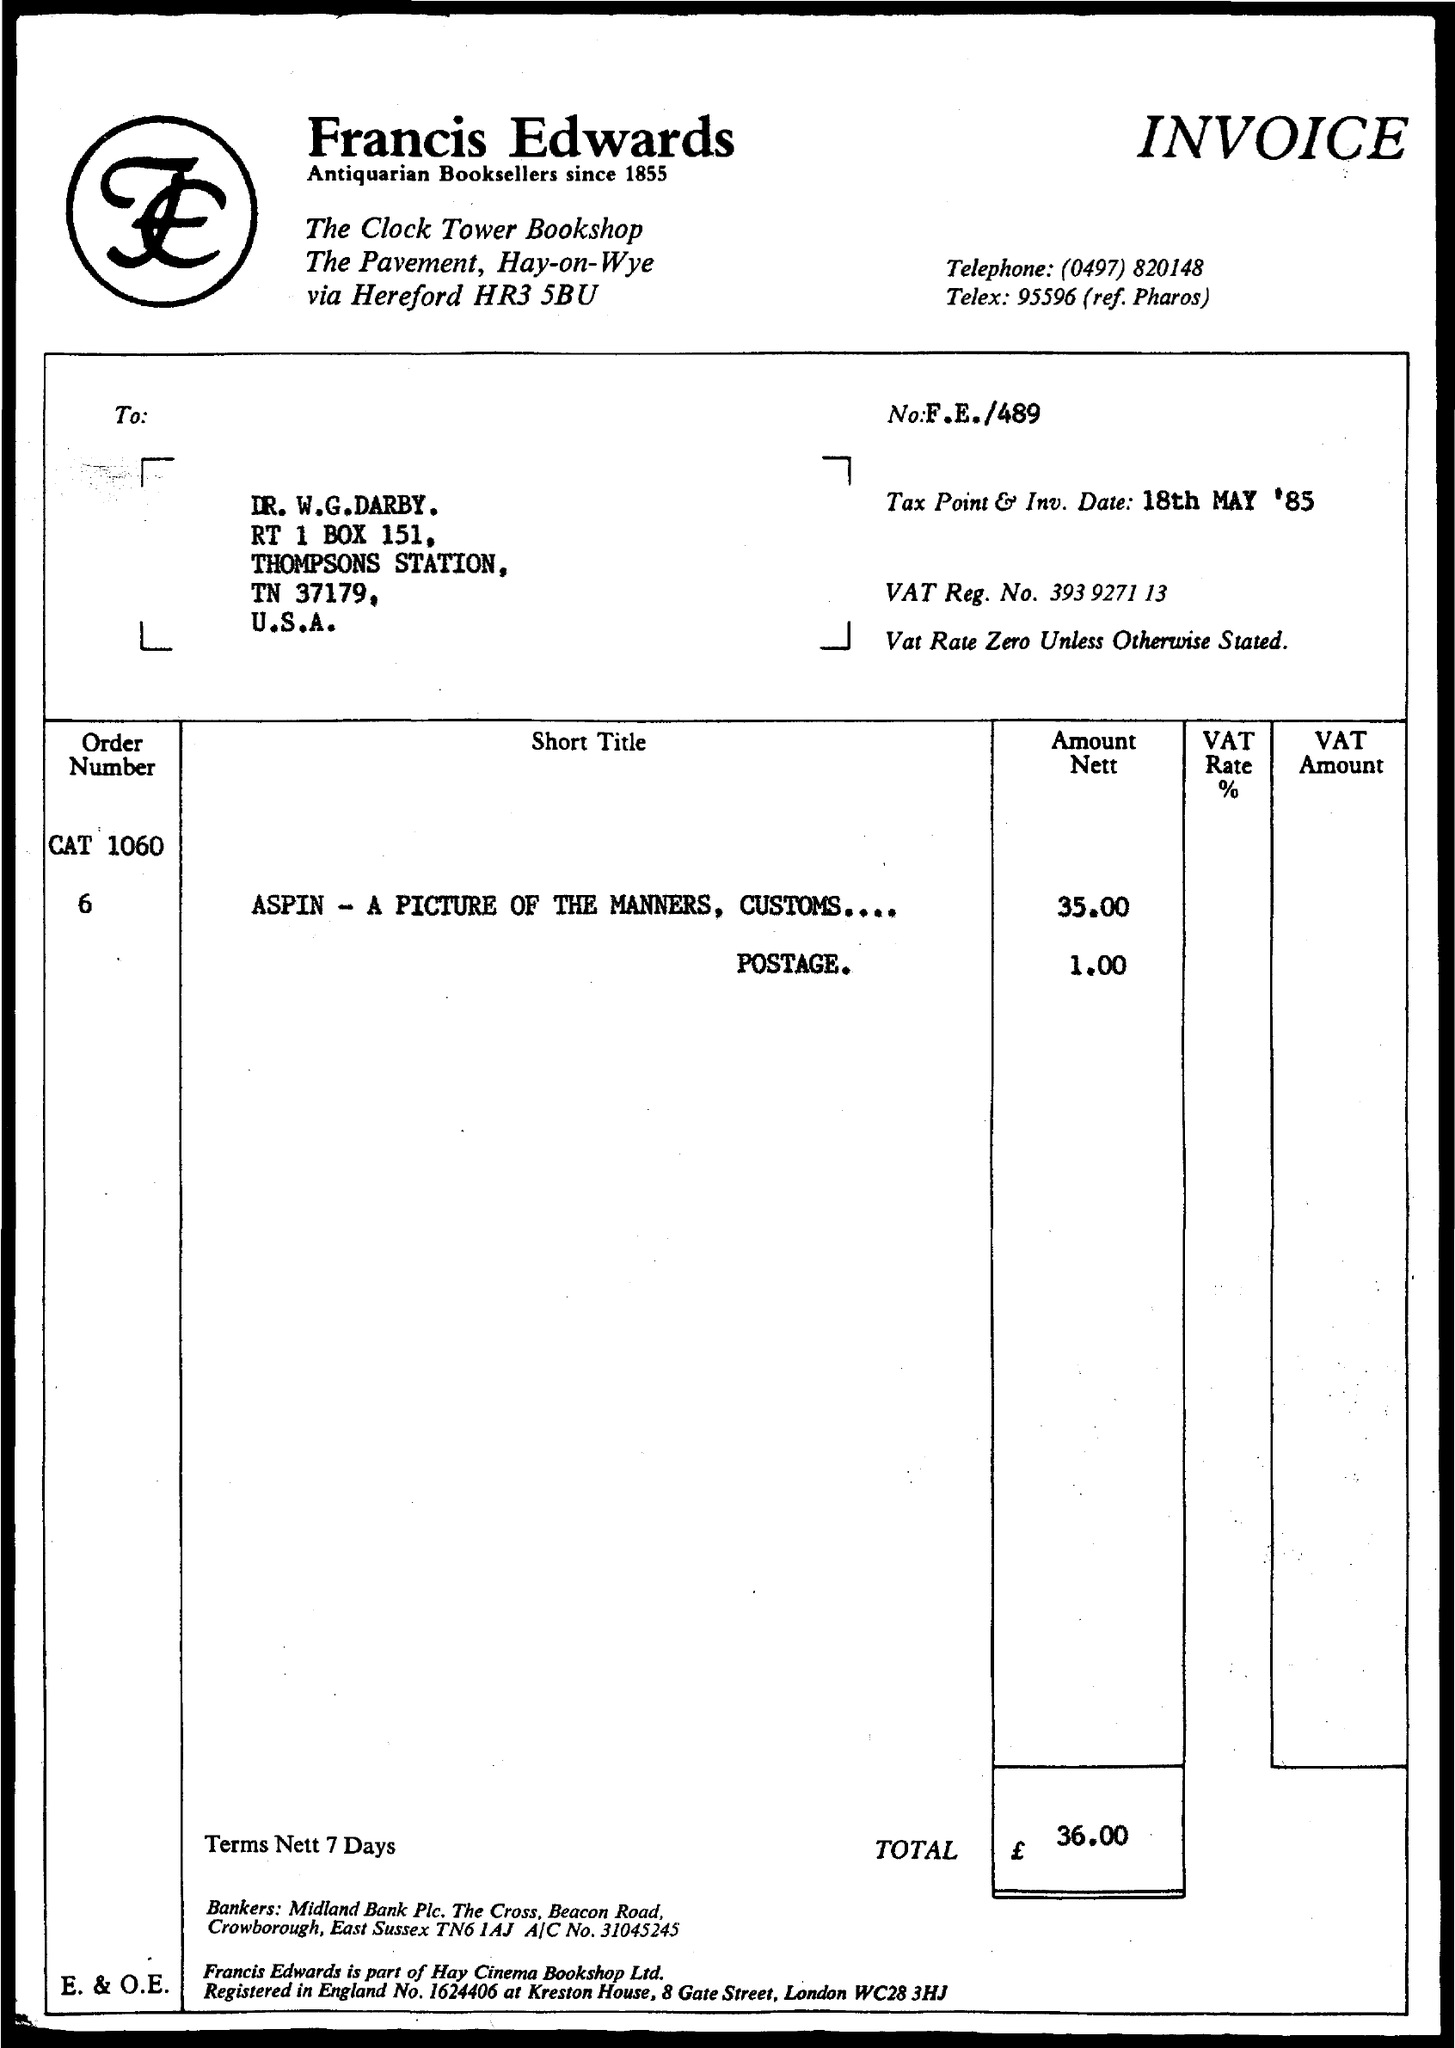Identify some key points in this picture. The VAT rate is 0 unless otherwise stated. The telephone number given is (0497) 820148. This is an invoice. On May 18th, 1985, the tax point and investment date were given. Francis Edwards is an antiquarian bookseller established in 1855. 